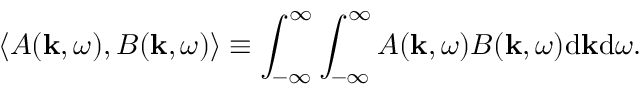Convert formula to latex. <formula><loc_0><loc_0><loc_500><loc_500>\langle A ( k , \omega ) , B ( k , \omega ) \rangle \equiv \int _ { - \infty } ^ { \infty } \int _ { - \infty } ^ { \infty } A ( k , \omega ) B ( k , \omega ) d k d \omega .</formula> 